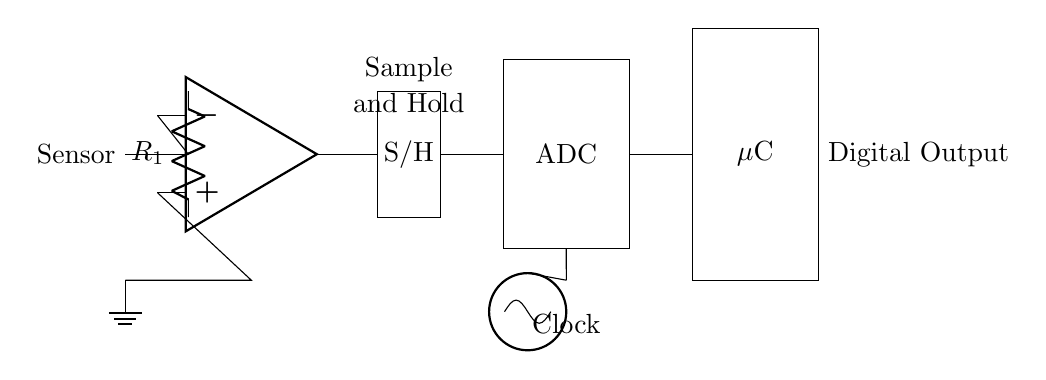What is the first component in the circuit? The first component is the sensor, which is the starting point for capturing analog signals.
Answer: sensor What component provides the analog signal conditioning? The operational amplifier, labeled as op amp, is used for amplifying and conditioning the analog signal from the sensor.
Answer: op amp How many major blocks are in this circuit diagram? There are four major blocks: Sensor, Sample and Hold, ADC, and Microcontroller, each performing distinct functions in the conversion process.
Answer: four What is the role of the Sample and Hold block? The Sample and Hold block captures the analog voltage at a specific moment in time and holds it steady for the ADC to convert it into a digital signal.
Answer: holds Which component introduces a timing or synchronization signal to the circuit? The oscillator introduces the clock signal, which synchronizes the data sampling and conversion process in the ADC and microcontroller.
Answer: oscillator What type of output does the Microcontroller generate? The Microcontroller generates a digital output signal after processing the converted data from the ADC.
Answer: Digital Output Why is an ADC necessary in this circuit? An ADC is necessary to convert the continuous analog signal from the sensor into discrete digital values that the microcontroller can process.
Answer: convert 